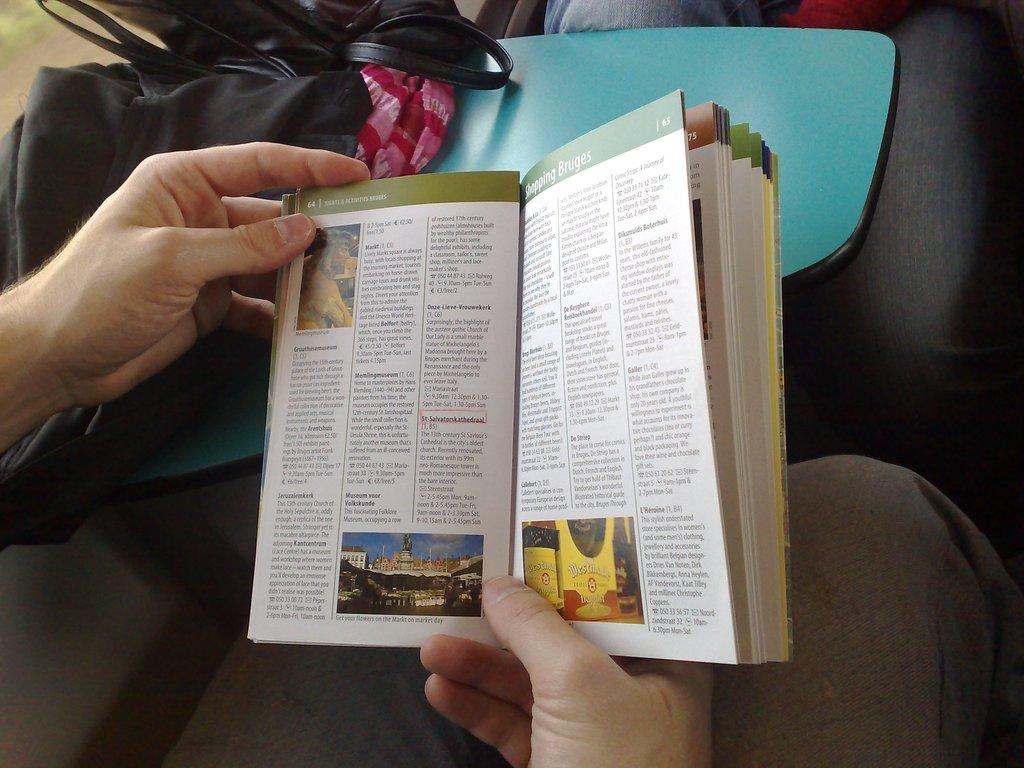<image>
Describe the image concisely. Someone holding a book opened to pages 64 and 65 about Shopping Bruges. 